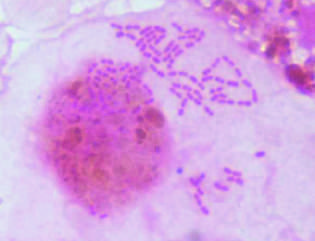does collagen stain preparation of a bronchoalveolar lavage specimen show gram-negative intracellular rods typical of members of enterobacteriaceae such as klebsiella pneumoniae or escherichia coli?
Answer the question using a single word or phrase. No 